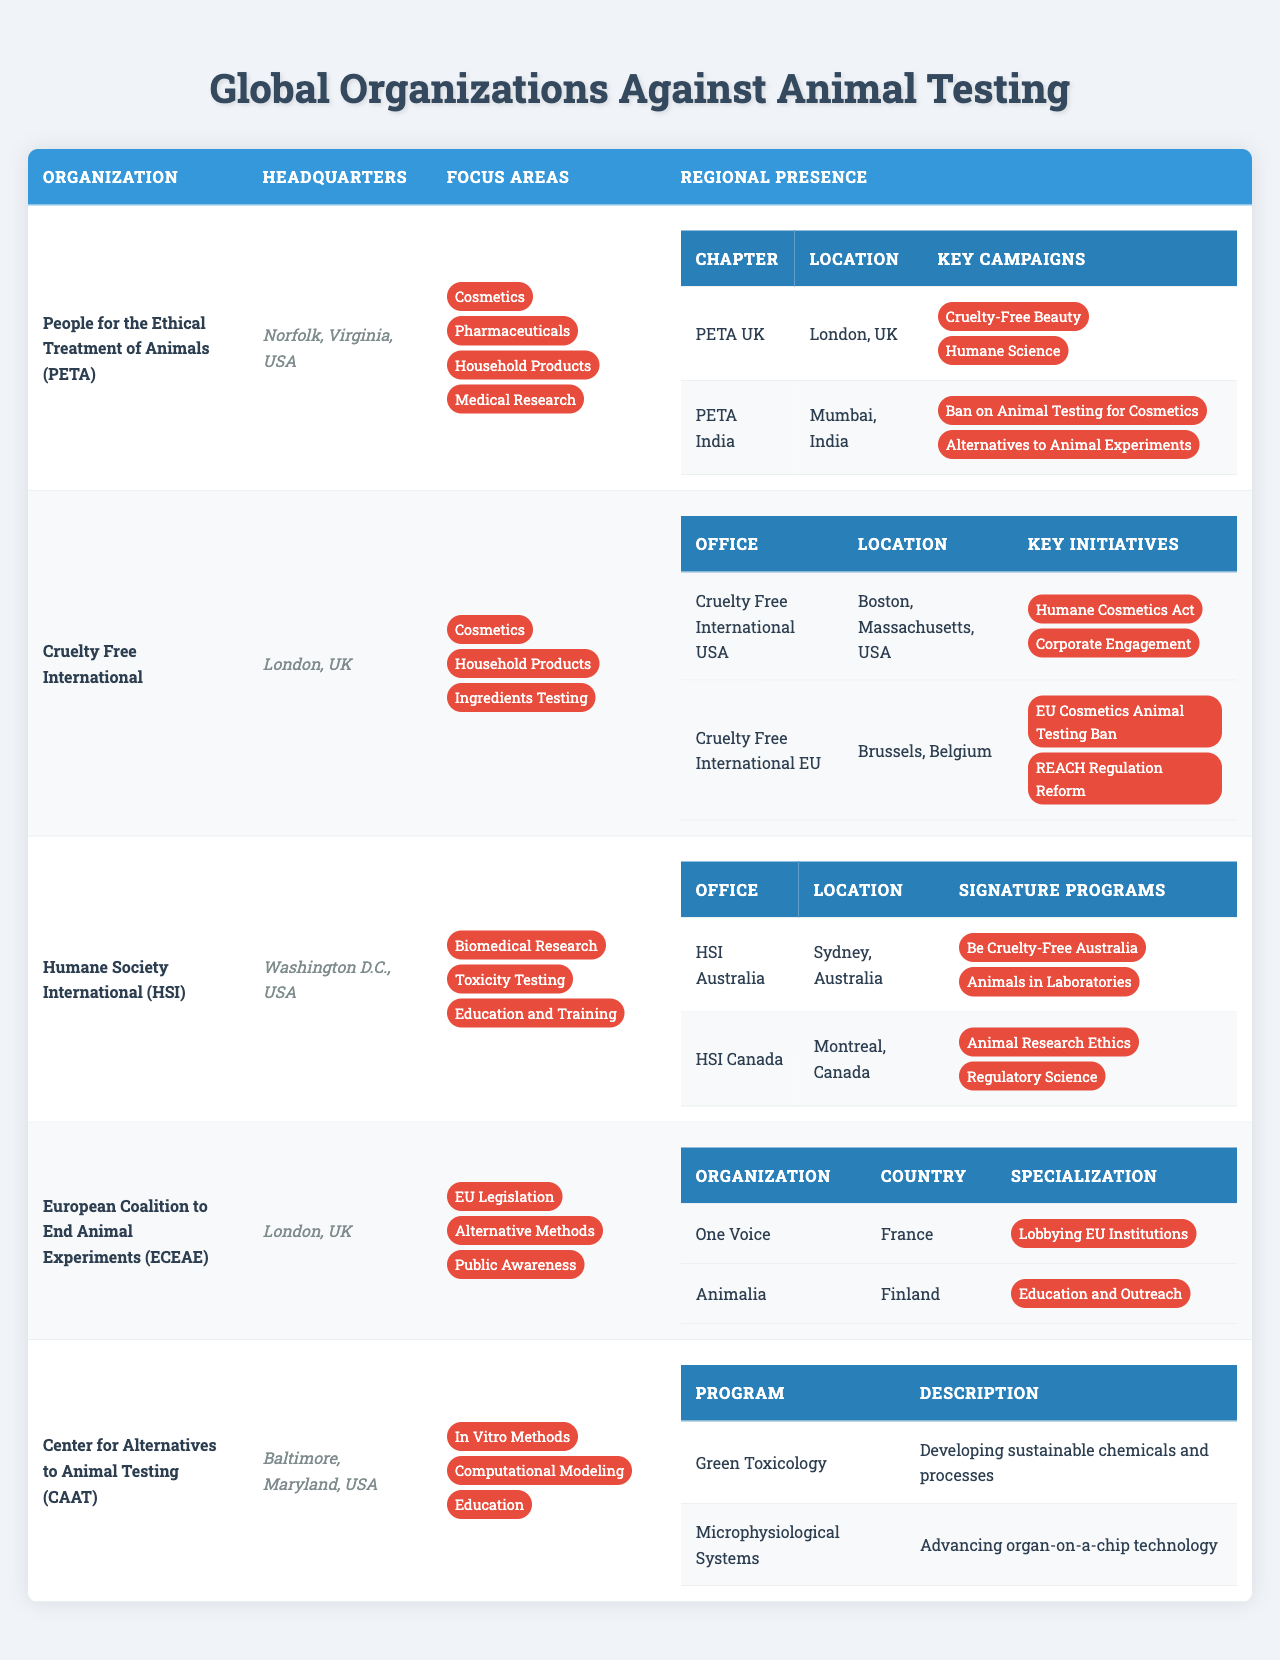What is the headquarters of People for the Ethical Treatment of Animals (PETA)? The table lists the information about PETA, including its headquarters which is stated as Norfolk, Virginia, USA.
Answer: Norfolk, Virginia, USA How many focus areas does Cruelty Free International have? The table shows three focus areas listed for Cruelty Free International: Cosmetics, Household Products, and Ingredients Testing. Therefore, the total is three.
Answer: 3 Does Humane Society International (HSI) have a regional presence in Canada? The table indicates that HSI has a country office in Montreal, Canada, confirming their presence there.
Answer: Yes What are the key initiatives of Cruelty Free International USA? The table specifies two key initiatives for Cruelty Free International USA: Humane Cosmetics Act and Corporate Engagement.
Answer: Humane Cosmetics Act and Corporate Engagement How many organizations are part of the European Coalition to End Animal Experiments (ECEAE)? ECEAE has two member organizations listed: One Voice from France and Animalia from Finland, summing up to two organizations in total.
Answer: 2 Which organization focuses on biomedical research? The table indicates that Humane Society International (HSI) has a focus area in Biomedical Research among others.
Answer: Humane Society International (HSI) Compare the headquarters locations for PETA and Cruelty Free International. PETA's headquarters is in Norfolk, Virginia, USA, while Cruelty Free International is headquartered in London, UK. Therefore, the comparison shows two different locations.
Answer: Norfolk, Virginia, USA and London, UK Identify the signature programs of HSI Australia. The table lists the signature programs for HSI Australia as Be Cruelty-Free Australia and Animals in Laboratories.
Answer: Be Cruelty-Free Australia and Animals in Laboratories Which organization has a focus on education in their work? The Center for Alternatives to Animal Testing (CAAT) has a focus area dedicated to Education, according to the data in the table.
Answer: Center for Alternatives to Animal Testing (CAAT) List all the regions where PETA has chapters. The table presents two regional chapters for PETA: PETA UK located in London, UK, and PETA India located in Mumbai, India.
Answer: London, UK and Mumbai, India How many key campaigns does PETA India have? The table mentions that PETA India has two key campaigns: Ban on Animal Testing for Cosmetics and Alternatives to Animal Experiments, totaling two campaigns.
Answer: 2 What common focus area do both PETA and Cruelty Free International share? Both PETA and Cruelty Free International have Cosmetics listed as one of their focus areas in the table.
Answer: Cosmetics What does the 'Green Toxicology' research program aim to achieve? The table describes the aim of the Green Toxicology program as developing sustainable chemicals and processes.
Answer: Developing sustainable chemicals and processes 